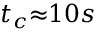Convert formula to latex. <formula><loc_0><loc_0><loc_500><loc_500>t _ { c } { \approx } 1 0 s</formula> 